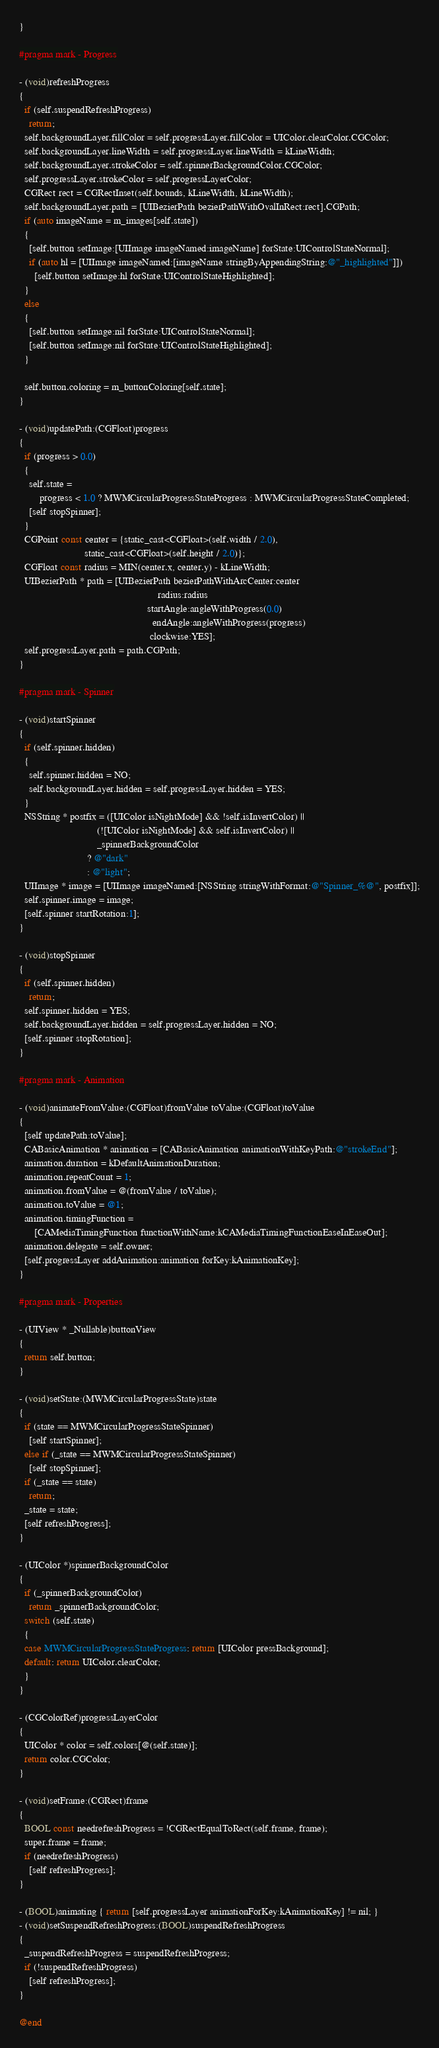<code> <loc_0><loc_0><loc_500><loc_500><_ObjectiveC_>}

#pragma mark - Progress

- (void)refreshProgress
{
  if (self.suspendRefreshProgress)
    return;
  self.backgroundLayer.fillColor = self.progressLayer.fillColor = UIColor.clearColor.CGColor;
  self.backgroundLayer.lineWidth = self.progressLayer.lineWidth = kLineWidth;
  self.backgroundLayer.strokeColor = self.spinnerBackgroundColor.CGColor;
  self.progressLayer.strokeColor = self.progressLayerColor;
  CGRect rect = CGRectInset(self.bounds, kLineWidth, kLineWidth);
  self.backgroundLayer.path = [UIBezierPath bezierPathWithOvalInRect:rect].CGPath;
  if (auto imageName = m_images[self.state])
  {
    [self.button setImage:[UIImage imageNamed:imageName] forState:UIControlStateNormal];
    if (auto hl = [UIImage imageNamed:[imageName stringByAppendingString:@"_highlighted"]])
      [self.button setImage:hl forState:UIControlStateHighlighted];
  }
  else
  {
    [self.button setImage:nil forState:UIControlStateNormal];
    [self.button setImage:nil forState:UIControlStateHighlighted];
  }

  self.button.coloring = m_buttonColoring[self.state];
}

- (void)updatePath:(CGFloat)progress
{
  if (progress > 0.0)
  {
    self.state =
        progress < 1.0 ? MWMCircularProgressStateProgress : MWMCircularProgressStateCompleted;
    [self stopSpinner];
  }
  CGPoint const center = {static_cast<CGFloat>(self.width / 2.0),
                          static_cast<CGFloat>(self.height / 2.0)};
  CGFloat const radius = MIN(center.x, center.y) - kLineWidth;
  UIBezierPath * path = [UIBezierPath bezierPathWithArcCenter:center
                                                       radius:radius
                                                   startAngle:angleWithProgress(0.0)
                                                     endAngle:angleWithProgress(progress)
                                                    clockwise:YES];
  self.progressLayer.path = path.CGPath;
}

#pragma mark - Spinner

- (void)startSpinner
{
  if (self.spinner.hidden)
  {
    self.spinner.hidden = NO;
    self.backgroundLayer.hidden = self.progressLayer.hidden = YES;
  }
  NSString * postfix = ([UIColor isNightMode] && !self.isInvertColor) ||
                               (![UIColor isNightMode] && self.isInvertColor) ||
                               _spinnerBackgroundColor
                           ? @"dark"
                           : @"light";
  UIImage * image = [UIImage imageNamed:[NSString stringWithFormat:@"Spinner_%@", postfix]];
  self.spinner.image = image;
  [self.spinner startRotation:1];
}

- (void)stopSpinner
{
  if (self.spinner.hidden)
    return;
  self.spinner.hidden = YES;
  self.backgroundLayer.hidden = self.progressLayer.hidden = NO;
  [self.spinner stopRotation];
}

#pragma mark - Animation

- (void)animateFromValue:(CGFloat)fromValue toValue:(CGFloat)toValue
{
  [self updatePath:toValue];
  CABasicAnimation * animation = [CABasicAnimation animationWithKeyPath:@"strokeEnd"];
  animation.duration = kDefaultAnimationDuration;
  animation.repeatCount = 1;
  animation.fromValue = @(fromValue / toValue);
  animation.toValue = @1;
  animation.timingFunction =
      [CAMediaTimingFunction functionWithName:kCAMediaTimingFunctionEaseInEaseOut];
  animation.delegate = self.owner;
  [self.progressLayer addAnimation:animation forKey:kAnimationKey];
}

#pragma mark - Properties

- (UIView * _Nullable)buttonView
{
  return self.button;
}

- (void)setState:(MWMCircularProgressState)state
{
  if (state == MWMCircularProgressStateSpinner)
    [self startSpinner];
  else if (_state == MWMCircularProgressStateSpinner)
    [self stopSpinner];
  if (_state == state)
    return;
  _state = state;
  [self refreshProgress];
}

- (UIColor *)spinnerBackgroundColor
{
  if (_spinnerBackgroundColor)
    return _spinnerBackgroundColor;
  switch (self.state)
  {
  case MWMCircularProgressStateProgress: return [UIColor pressBackground];
  default: return UIColor.clearColor;
  }
}

- (CGColorRef)progressLayerColor
{
  UIColor * color = self.colors[@(self.state)];
  return color.CGColor;
}

- (void)setFrame:(CGRect)frame
{
  BOOL const needrefreshProgress = !CGRectEqualToRect(self.frame, frame);
  super.frame = frame;
  if (needrefreshProgress)
    [self refreshProgress];
}

- (BOOL)animating { return [self.progressLayer animationForKey:kAnimationKey] != nil; }
- (void)setSuspendRefreshProgress:(BOOL)suspendRefreshProgress
{
  _suspendRefreshProgress = suspendRefreshProgress;
  if (!suspendRefreshProgress)
    [self refreshProgress];
}

@end
</code> 